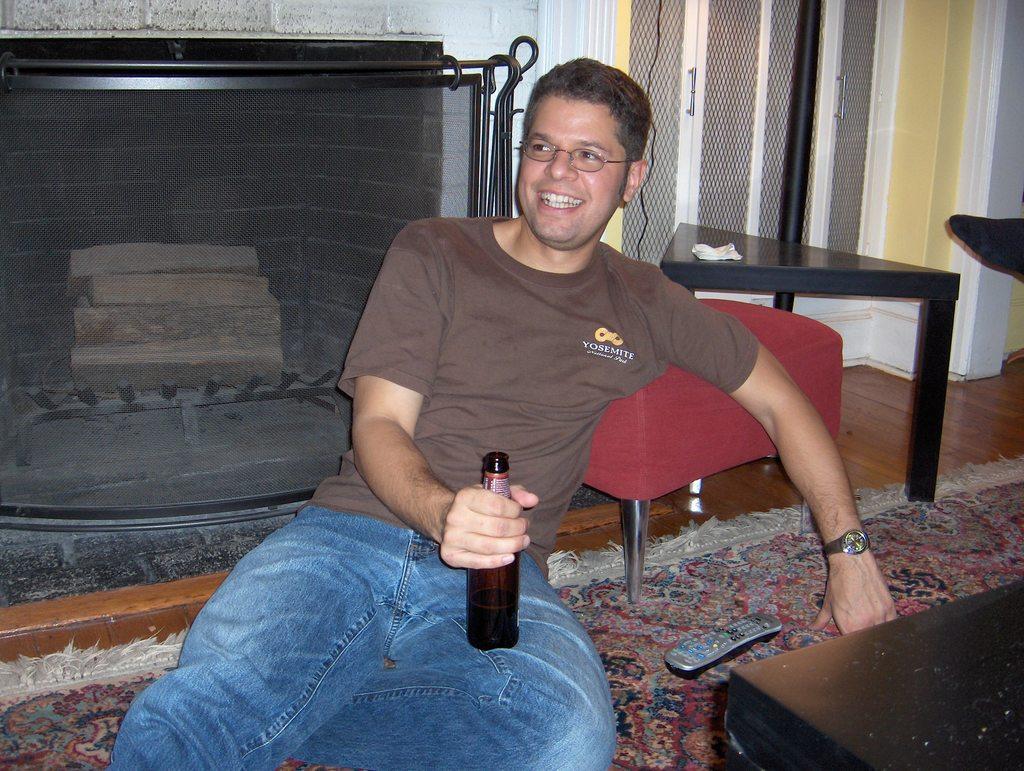Could you give a brief overview of what you see in this image? In this image, we can see a person sitting and wearing glasses and holding a bottle. In the background, there are stands and we can see a chair and there is a pole and we can see a cupboard and there is a fire place. At the bottom, there is a remote and a carpet and there is a black color object on the floor. 